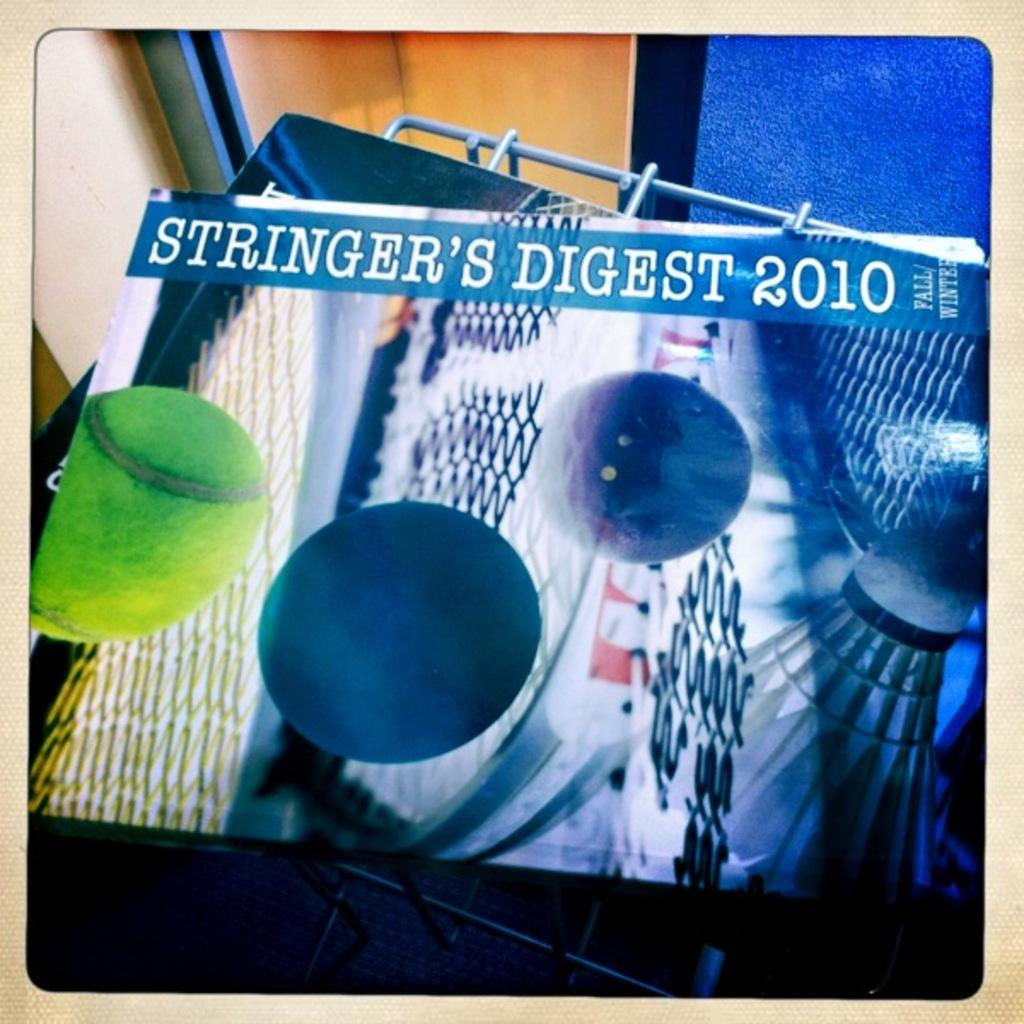What is the main object in the image? There is a stand in the image. What is on the stand? There are papers on the stand. What can be seen at the top of the image? There is a wall at the top of the image. Is there a trail leading to the stand in the image? There is no trail visible in the image; it only shows a stand with papers and a wall at the top. 